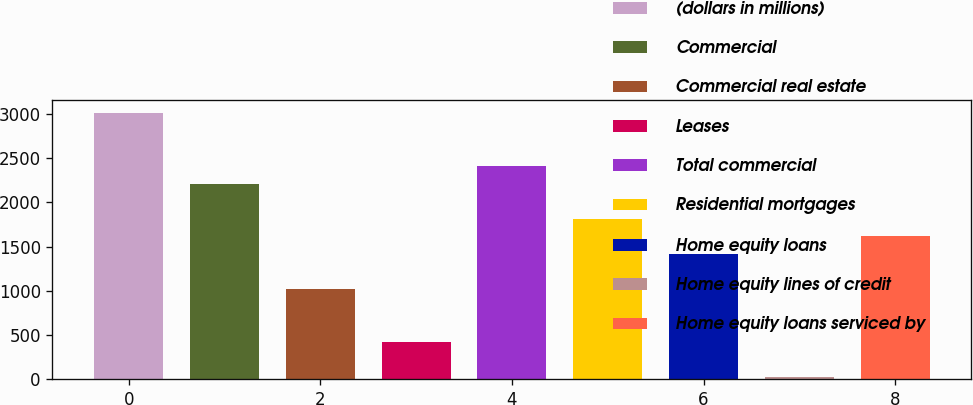Convert chart. <chart><loc_0><loc_0><loc_500><loc_500><bar_chart><fcel>(dollars in millions)<fcel>Commercial<fcel>Commercial real estate<fcel>Leases<fcel>Total commercial<fcel>Residential mortgages<fcel>Home equity loans<fcel>Home equity lines of credit<fcel>Home equity loans serviced by<nl><fcel>3012<fcel>2213.6<fcel>1016<fcel>417.2<fcel>2413.2<fcel>1814.4<fcel>1415.2<fcel>18<fcel>1614.8<nl></chart> 